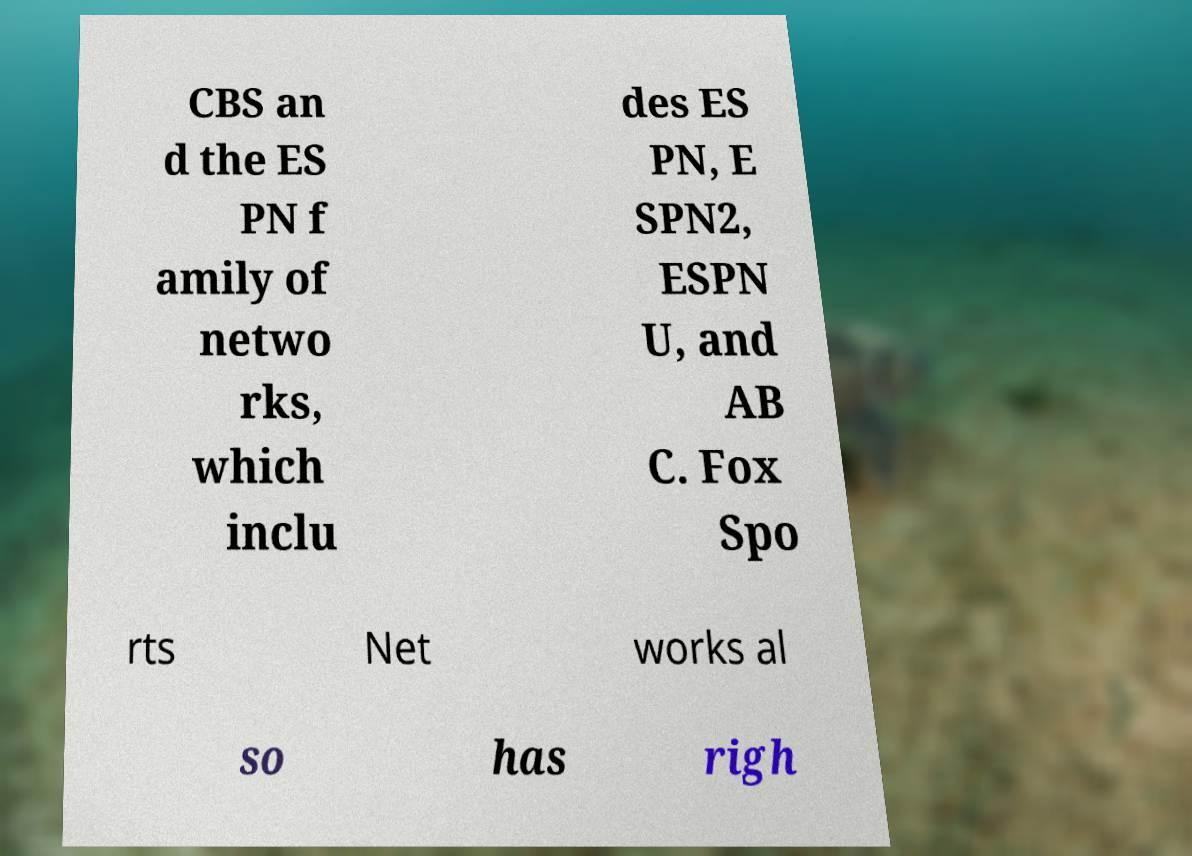Can you read and provide the text displayed in the image?This photo seems to have some interesting text. Can you extract and type it out for me? CBS an d the ES PN f amily of netwo rks, which inclu des ES PN, E SPN2, ESPN U, and AB C. Fox Spo rts Net works al so has righ 